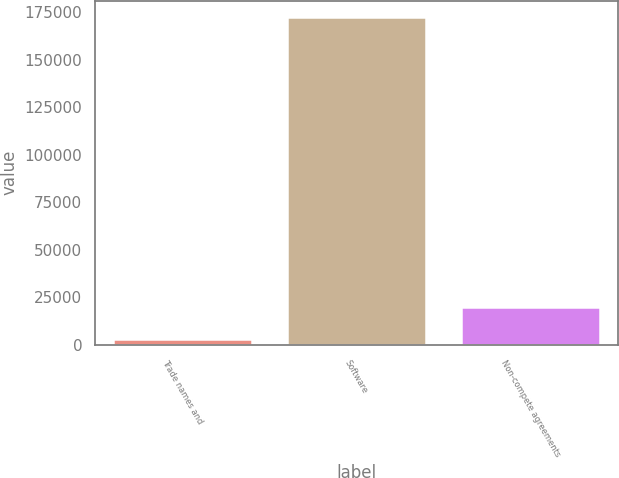Convert chart. <chart><loc_0><loc_0><loc_500><loc_500><bar_chart><fcel>Trade names and<fcel>Software<fcel>Non-compete agreements<nl><fcel>3096<fcel>172533<fcel>20039.7<nl></chart> 